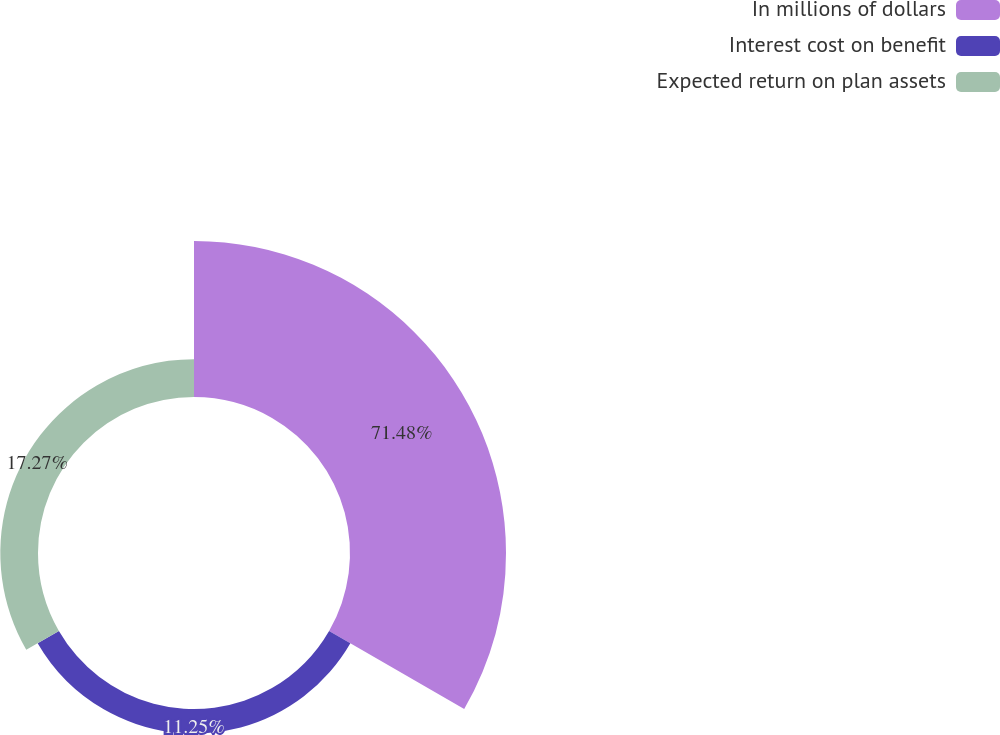Convert chart to OTSL. <chart><loc_0><loc_0><loc_500><loc_500><pie_chart><fcel>In millions of dollars<fcel>Interest cost on benefit<fcel>Expected return on plan assets<nl><fcel>71.48%<fcel>11.25%<fcel>17.27%<nl></chart> 